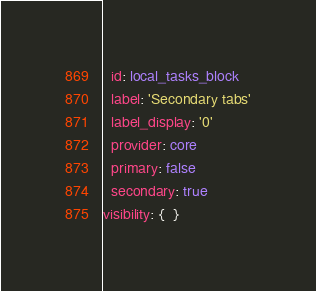<code> <loc_0><loc_0><loc_500><loc_500><_YAML_>  id: local_tasks_block
  label: 'Secondary tabs'
  label_display: '0'
  provider: core
  primary: false
  secondary: true
visibility: {  }
</code> 